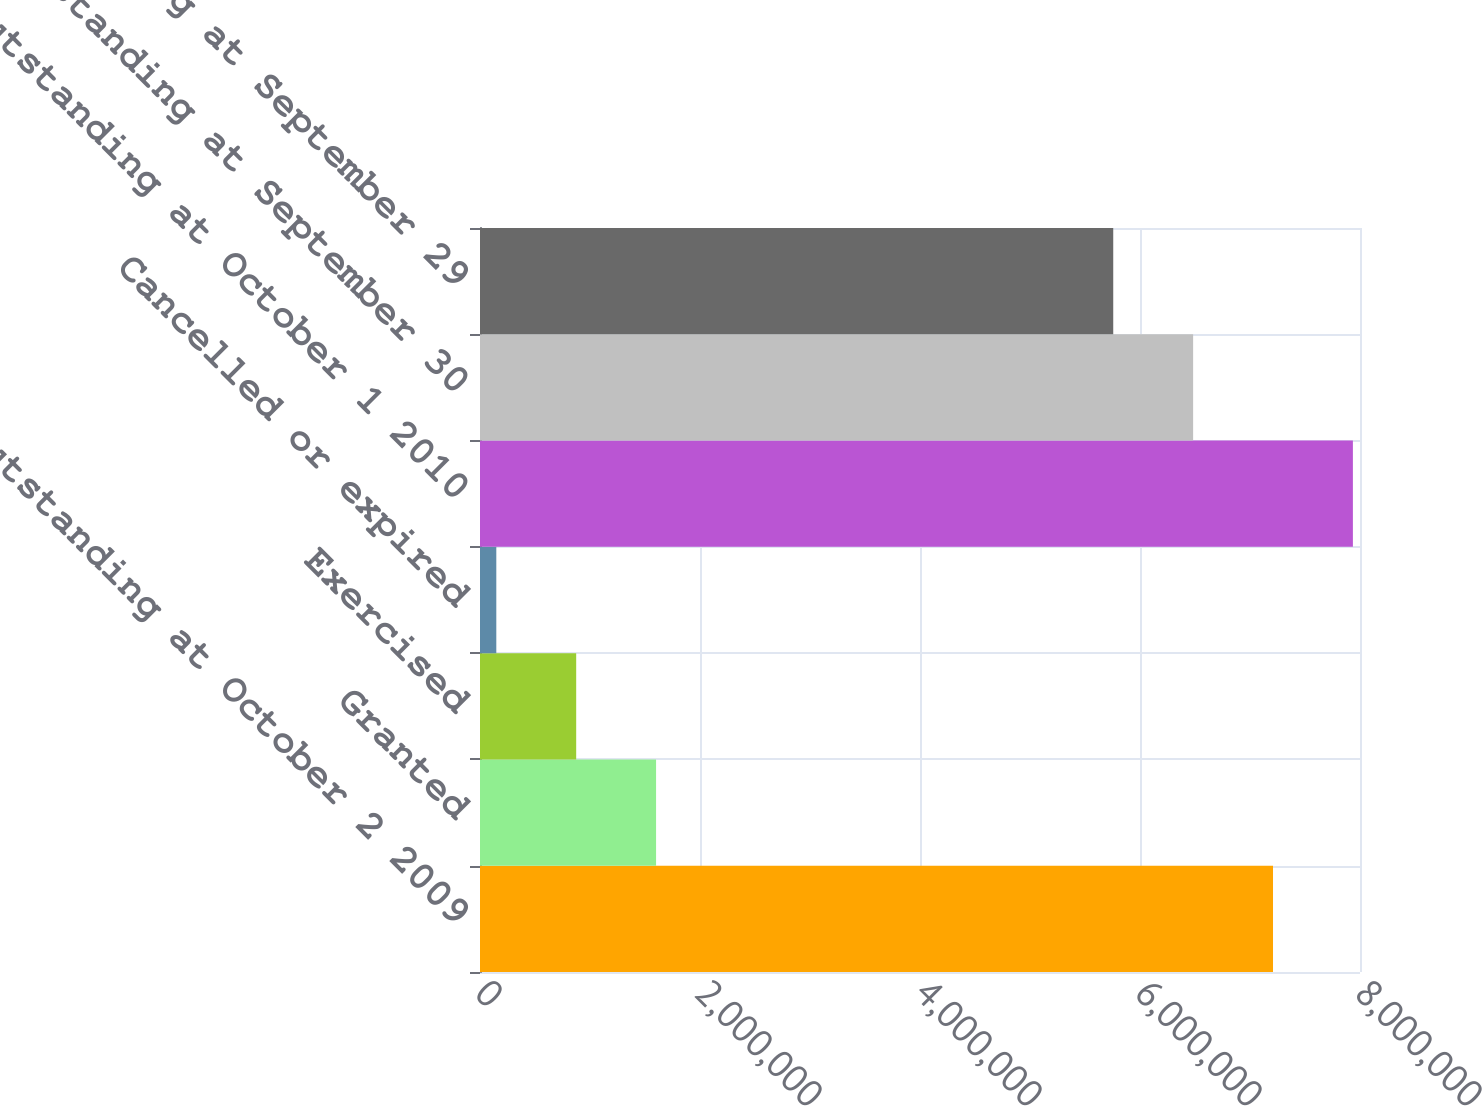Convert chart to OTSL. <chart><loc_0><loc_0><loc_500><loc_500><bar_chart><fcel>Outstanding at October 2 2009<fcel>Granted<fcel>Exercised<fcel>Cancelled or expired<fcel>Outstanding at October 1 2010<fcel>Outstanding at September 30<fcel>Outstanding at September 29<nl><fcel>7.2092e+06<fcel>1.60071e+06<fcel>874471<fcel>148237<fcel>7.93544e+06<fcel>6.48297e+06<fcel>5.75673e+06<nl></chart> 